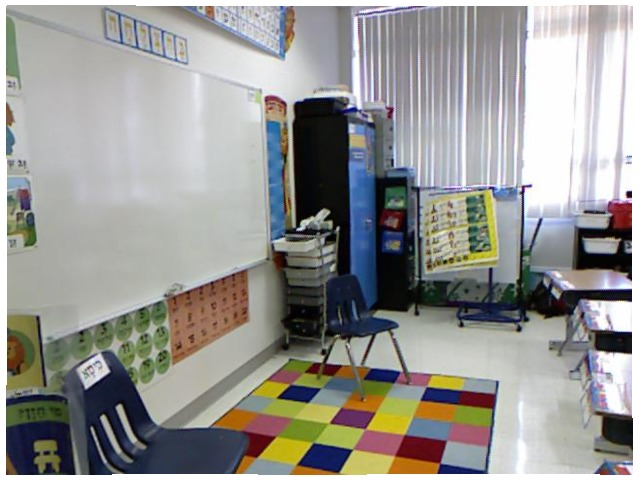<image>
Is there a chair in front of the whiteboard? Yes. The chair is positioned in front of the whiteboard, appearing closer to the camera viewpoint. Is the cupboard in front of the paper? No. The cupboard is not in front of the paper. The spatial positioning shows a different relationship between these objects. Where is the chair in relation to the paper? Is it in the paper? No. The chair is not contained within the paper. These objects have a different spatial relationship. Is the chair next to the carpet? No. The chair is not positioned next to the carpet. They are located in different areas of the scene. Where is the blinds in relation to the whiteboard? Is it next to the whiteboard? No. The blinds is not positioned next to the whiteboard. They are located in different areas of the scene. 